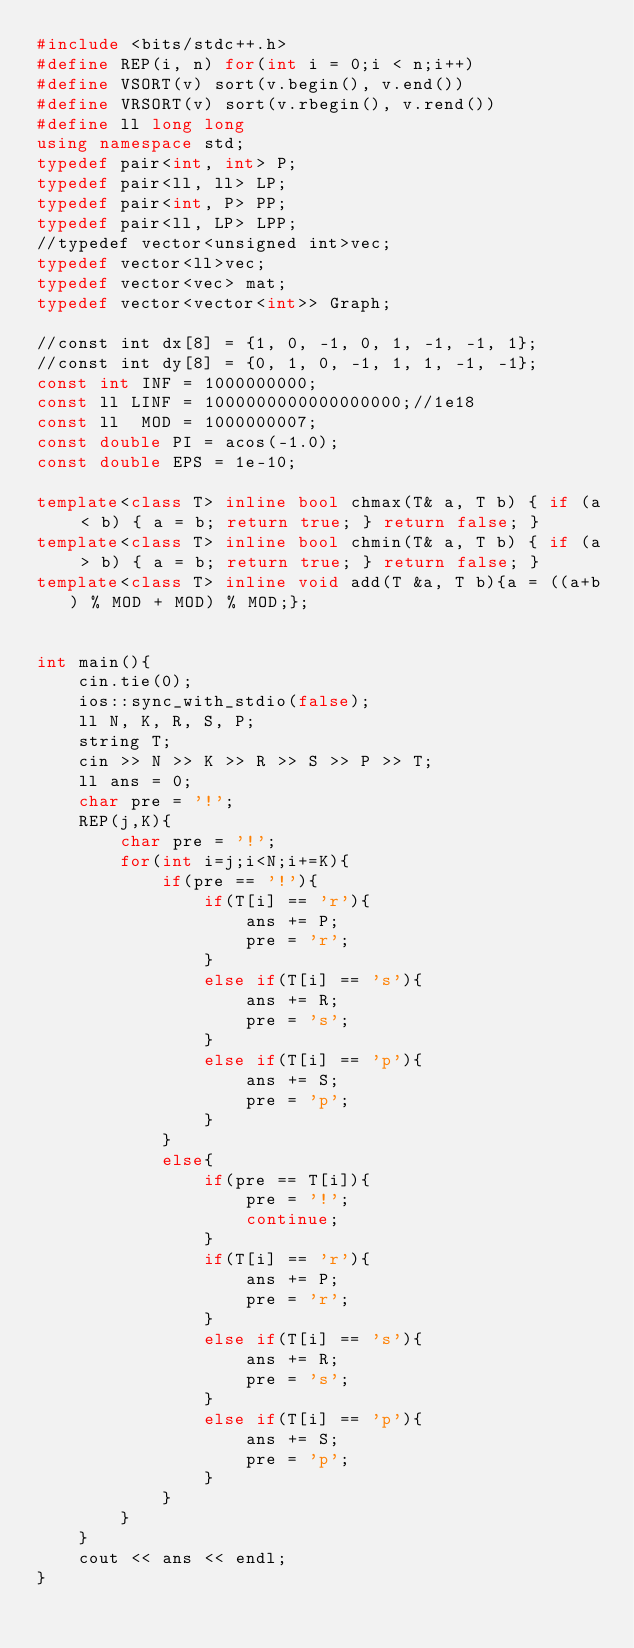Convert code to text. <code><loc_0><loc_0><loc_500><loc_500><_C++_>#include <bits/stdc++.h>
#define REP(i, n) for(int i = 0;i < n;i++)
#define VSORT(v) sort(v.begin(), v.end())
#define VRSORT(v) sort(v.rbegin(), v.rend())
#define ll long long
using namespace std;
typedef pair<int, int> P;
typedef pair<ll, ll> LP;
typedef pair<int, P> PP;
typedef pair<ll, LP> LPP;
//typedef vector<unsigned int>vec;
typedef vector<ll>vec;
typedef vector<vec> mat;
typedef vector<vector<int>> Graph;

//const int dx[8] = {1, 0, -1, 0, 1, -1, -1, 1};
//const int dy[8] = {0, 1, 0, -1, 1, 1, -1, -1};
const int INF = 1000000000;
const ll LINF = 1000000000000000000;//1e18
const ll  MOD = 1000000007;
const double PI = acos(-1.0);
const double EPS = 1e-10;

template<class T> inline bool chmax(T& a, T b) { if (a < b) { a = b; return true; } return false; }
template<class T> inline bool chmin(T& a, T b) { if (a > b) { a = b; return true; } return false; }
template<class T> inline void add(T &a, T b){a = ((a+b) % MOD + MOD) % MOD;};


int main(){
    cin.tie(0);
    ios::sync_with_stdio(false);
    ll N, K, R, S, P;
    string T;
    cin >> N >> K >> R >> S >> P >> T;
    ll ans = 0;
    char pre = '!';
    REP(j,K){
        char pre = '!';
        for(int i=j;i<N;i+=K){
            if(pre == '!'){
                if(T[i] == 'r'){
                    ans += P;
                    pre = 'r';
                }
                else if(T[i] == 's'){
                    ans += R;
                    pre = 's';
                }
                else if(T[i] == 'p'){
                    ans += S;
                    pre = 'p';
                }
            }
            else{
                if(pre == T[i]){
                    pre = '!';
                    continue;
                }
                if(T[i] == 'r'){
                    ans += P;
                    pre = 'r';
                }
                else if(T[i] == 's'){
                    ans += R;
                    pre = 's';
                }
                else if(T[i] == 'p'){
                    ans += S;
                    pre = 'p';
                }
            }
        }
    }
    cout << ans << endl;
}</code> 